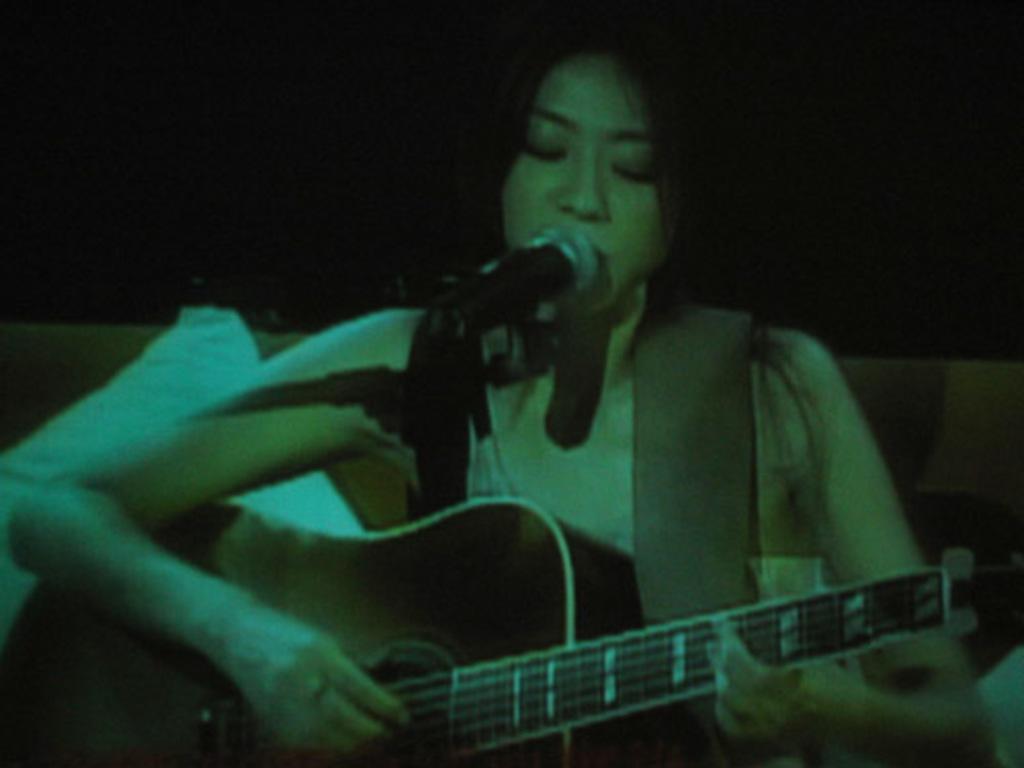Could you give a brief overview of what you see in this image? In the center we can see one woman sitting on couch and holding guitar. In front there is a microphone. In the background there is a wall. 